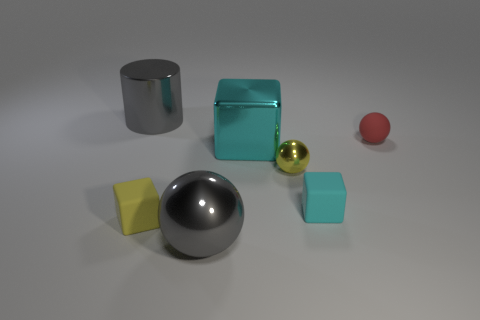Subtract all small spheres. How many spheres are left? 1 Add 2 yellow metal objects. How many objects exist? 9 Subtract all yellow blocks. How many blocks are left? 2 Subtract all blue cylinders. Subtract all cyan balls. How many cylinders are left? 1 Subtract all green balls. How many gray blocks are left? 0 Subtract all tiny cyan things. Subtract all small yellow rubber blocks. How many objects are left? 5 Add 1 small shiny things. How many small shiny things are left? 2 Add 1 small cyan things. How many small cyan things exist? 2 Subtract 1 yellow spheres. How many objects are left? 6 Subtract all cylinders. How many objects are left? 6 